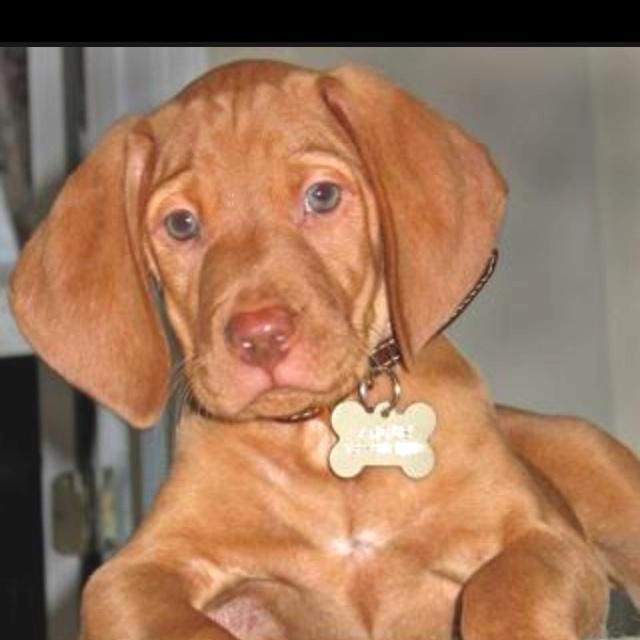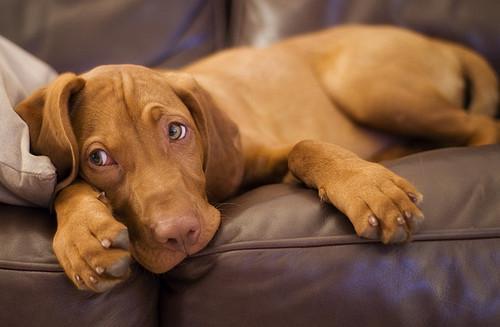The first image is the image on the left, the second image is the image on the right. For the images displayed, is the sentence "Each image contains one red-orange dog, each dog has short hair and a closed mouth, and one image shows a dog with an upright head facing forward." factually correct? Answer yes or no. Yes. The first image is the image on the left, the second image is the image on the right. Considering the images on both sides, is "There are two dogs." valid? Answer yes or no. Yes. 